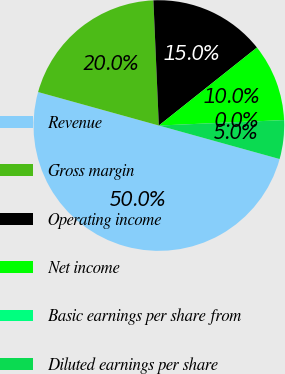Convert chart to OTSL. <chart><loc_0><loc_0><loc_500><loc_500><pie_chart><fcel>Revenue<fcel>Gross margin<fcel>Operating income<fcel>Net income<fcel>Basic earnings per share from<fcel>Diluted earnings per share<nl><fcel>50.0%<fcel>20.0%<fcel>15.0%<fcel>10.0%<fcel>0.0%<fcel>5.0%<nl></chart> 